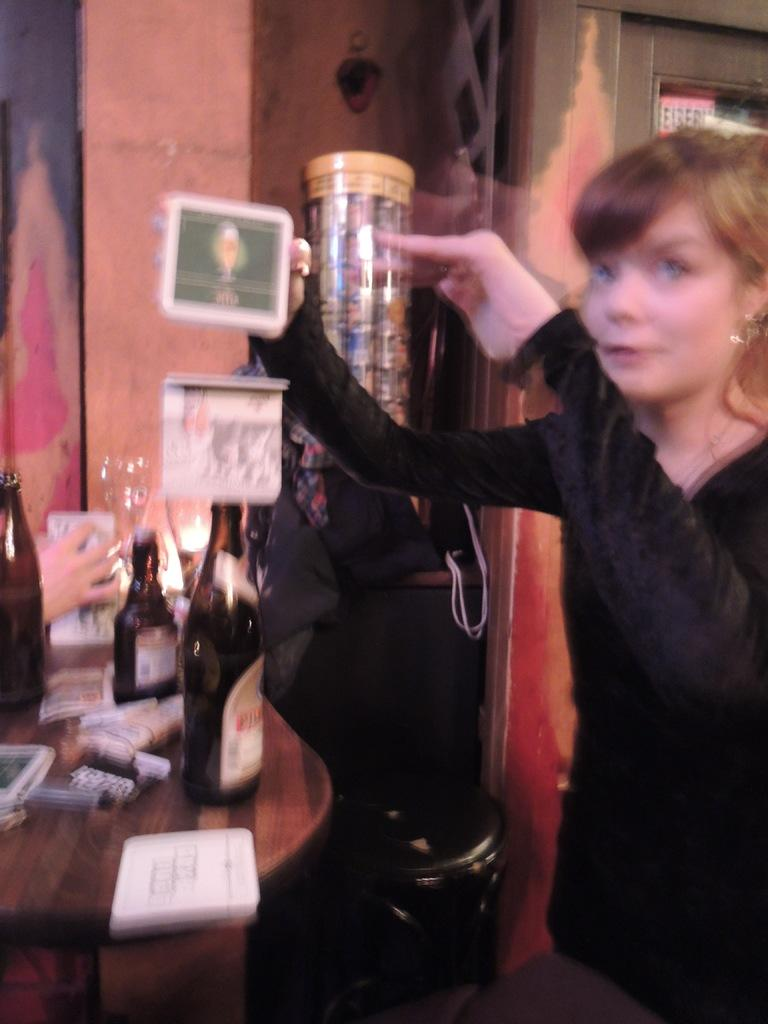Who is the main subject in the image? There is a lady in the image. What is the lady wearing? The lady is wearing a black dress. What is the lady holding in the image? The lady is holding a photo frame. What can be seen on the table in the image? There are bottles and other items on the table. What is visible in the background of the image? There is a wall in the background of the image. What type of fear can be seen on the lady's face in the image? There is no indication of fear on the lady's face in the image. What type of quill is visible on the table in the image? There is no quill present on the table in the image. 